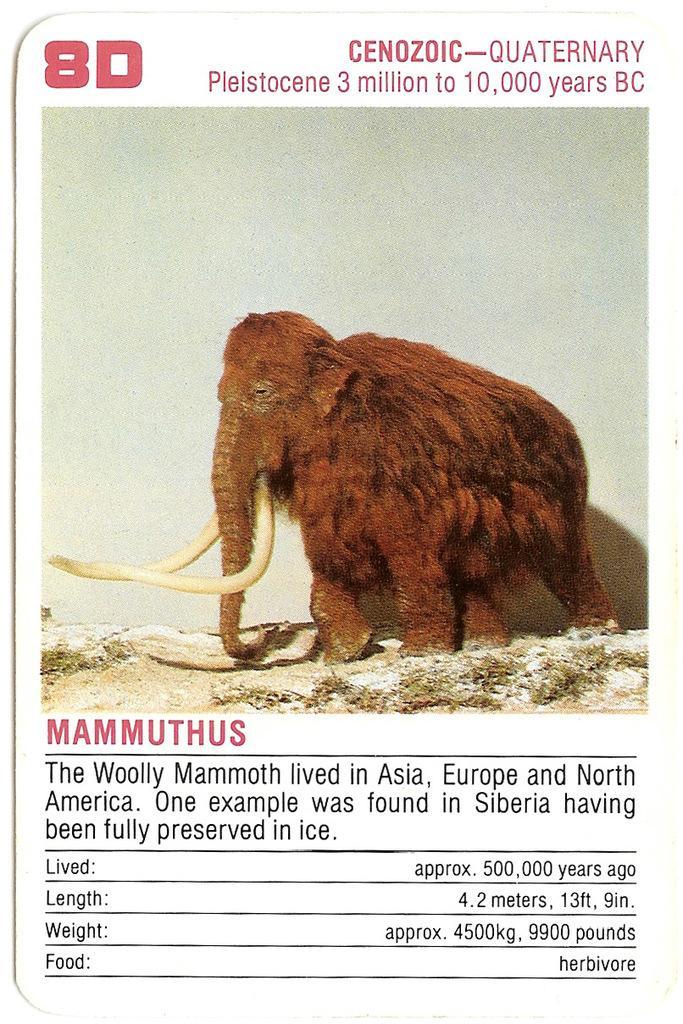Please provide a concise description of this image. In this picture I can see an information card. In this card, I can see a picture of mammoth animal and information about that animal.   